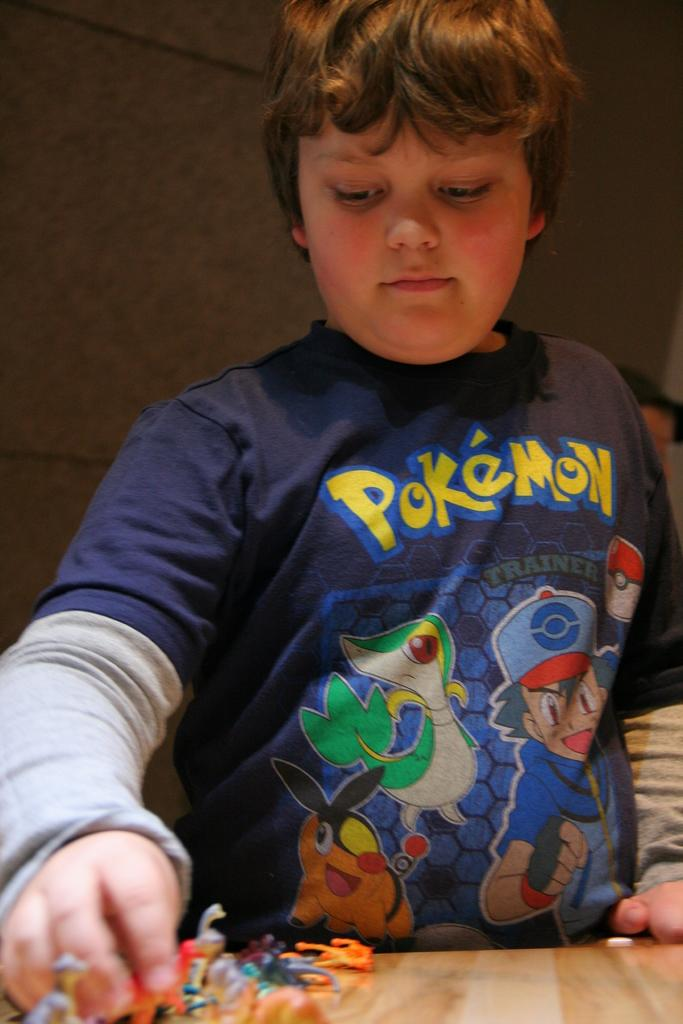What is the main subject in the front of the image? There is a kid in the front of the image. What is located at the bottom of the image? There is a table at the bottom of the image. What can be found on the table? There are toys on the table. What can be seen in the background of the image? There is a wall in the background of the image. How many yams are present on the table in the image? There are no yams present on the table in the image; there are only toys. How long does it take for the kid to finish playing with the toys in the image? The image does not provide information about the duration of the kid's playtime, so it cannot be determined from the image. 